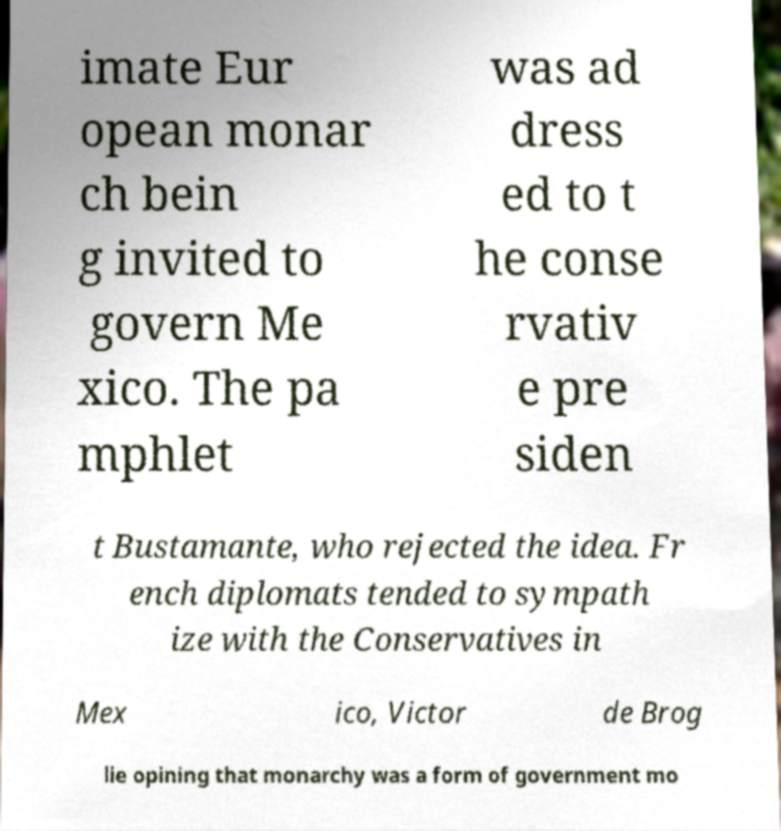Can you accurately transcribe the text from the provided image for me? imate Eur opean monar ch bein g invited to govern Me xico. The pa mphlet was ad dress ed to t he conse rvativ e pre siden t Bustamante, who rejected the idea. Fr ench diplomats tended to sympath ize with the Conservatives in Mex ico, Victor de Brog lie opining that monarchy was a form of government mo 